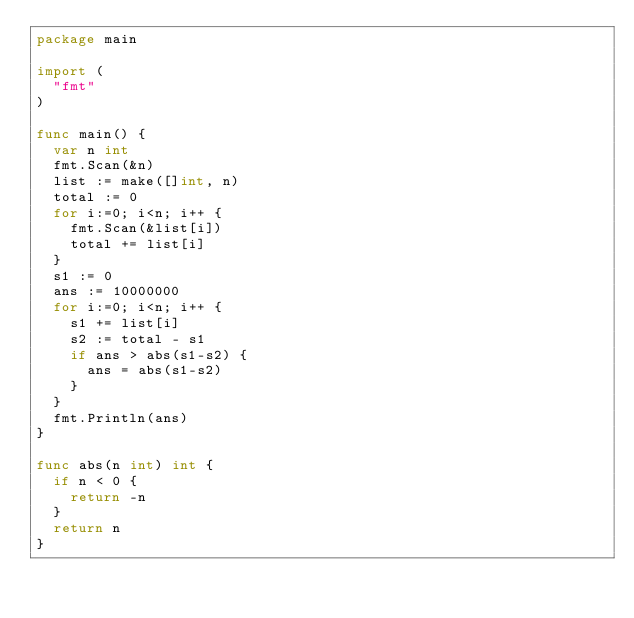Convert code to text. <code><loc_0><loc_0><loc_500><loc_500><_Go_>package main

import (
	"fmt"
)

func main() {
	var n int
	fmt.Scan(&n)
	list := make([]int, n)
	total := 0
	for i:=0; i<n; i++ {
		fmt.Scan(&list[i])
		total += list[i]
	}
	s1 := 0
	ans := 10000000
	for i:=0; i<n; i++ {
		s1 += list[i]
		s2 := total - s1
		if ans > abs(s1-s2) {
			ans = abs(s1-s2)
		}
	}
	fmt.Println(ans)
}

func abs(n int) int {
	if n < 0 {
		return -n
	}
	return n
}
</code> 